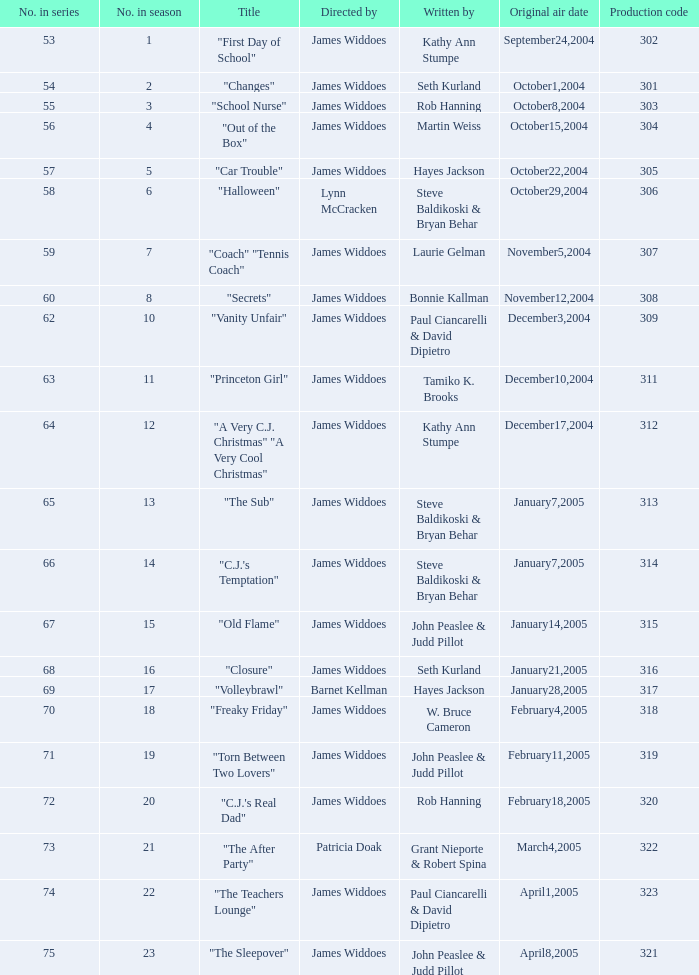What date was the episode originally aired that was directed by James Widdoes and the production code is 320? February18,2005. 